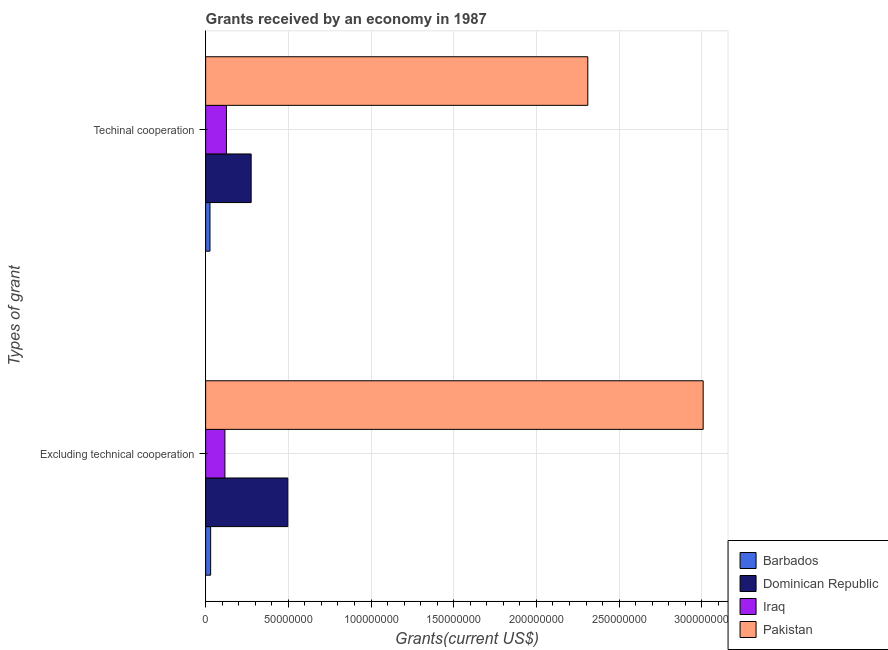How many groups of bars are there?
Your answer should be compact. 2. Are the number of bars on each tick of the Y-axis equal?
Provide a succinct answer. Yes. How many bars are there on the 1st tick from the bottom?
Give a very brief answer. 4. What is the label of the 2nd group of bars from the top?
Give a very brief answer. Excluding technical cooperation. What is the amount of grants received(including technical cooperation) in Dominican Republic?
Keep it short and to the point. 2.75e+07. Across all countries, what is the maximum amount of grants received(including technical cooperation)?
Provide a short and direct response. 2.31e+08. Across all countries, what is the minimum amount of grants received(including technical cooperation)?
Give a very brief answer. 2.63e+06. In which country was the amount of grants received(including technical cooperation) maximum?
Make the answer very short. Pakistan. In which country was the amount of grants received(excluding technical cooperation) minimum?
Your answer should be compact. Barbados. What is the total amount of grants received(including technical cooperation) in the graph?
Provide a succinct answer. 2.74e+08. What is the difference between the amount of grants received(including technical cooperation) in Dominican Republic and that in Barbados?
Provide a short and direct response. 2.49e+07. What is the difference between the amount of grants received(including technical cooperation) in Barbados and the amount of grants received(excluding technical cooperation) in Pakistan?
Your answer should be compact. -2.98e+08. What is the average amount of grants received(excluding technical cooperation) per country?
Provide a short and direct response. 9.13e+07. What is the difference between the amount of grants received(excluding technical cooperation) and amount of grants received(including technical cooperation) in Iraq?
Your response must be concise. -9.30e+05. In how many countries, is the amount of grants received(excluding technical cooperation) greater than 130000000 US$?
Your answer should be compact. 1. What is the ratio of the amount of grants received(excluding technical cooperation) in Dominican Republic to that in Pakistan?
Provide a succinct answer. 0.17. Is the amount of grants received(excluding technical cooperation) in Pakistan less than that in Dominican Republic?
Keep it short and to the point. No. In how many countries, is the amount of grants received(including technical cooperation) greater than the average amount of grants received(including technical cooperation) taken over all countries?
Keep it short and to the point. 1. What does the 4th bar from the top in Excluding technical cooperation represents?
Give a very brief answer. Barbados. What does the 2nd bar from the bottom in Excluding technical cooperation represents?
Provide a succinct answer. Dominican Republic. How many countries are there in the graph?
Provide a short and direct response. 4. What is the difference between two consecutive major ticks on the X-axis?
Your answer should be compact. 5.00e+07. Does the graph contain any zero values?
Offer a terse response. No. Does the graph contain grids?
Ensure brevity in your answer.  Yes. Where does the legend appear in the graph?
Keep it short and to the point. Bottom right. How many legend labels are there?
Your answer should be compact. 4. How are the legend labels stacked?
Your response must be concise. Vertical. What is the title of the graph?
Ensure brevity in your answer.  Grants received by an economy in 1987. What is the label or title of the X-axis?
Provide a short and direct response. Grants(current US$). What is the label or title of the Y-axis?
Your response must be concise. Types of grant. What is the Grants(current US$) of Barbados in Excluding technical cooperation?
Offer a terse response. 3.03e+06. What is the Grants(current US$) in Dominican Republic in Excluding technical cooperation?
Make the answer very short. 4.97e+07. What is the Grants(current US$) of Iraq in Excluding technical cooperation?
Offer a very short reply. 1.16e+07. What is the Grants(current US$) in Pakistan in Excluding technical cooperation?
Provide a succinct answer. 3.01e+08. What is the Grants(current US$) of Barbados in Techinal cooperation?
Provide a short and direct response. 2.63e+06. What is the Grants(current US$) of Dominican Republic in Techinal cooperation?
Your response must be concise. 2.75e+07. What is the Grants(current US$) in Iraq in Techinal cooperation?
Keep it short and to the point. 1.26e+07. What is the Grants(current US$) of Pakistan in Techinal cooperation?
Provide a short and direct response. 2.31e+08. Across all Types of grant, what is the maximum Grants(current US$) in Barbados?
Your response must be concise. 3.03e+06. Across all Types of grant, what is the maximum Grants(current US$) in Dominican Republic?
Your response must be concise. 4.97e+07. Across all Types of grant, what is the maximum Grants(current US$) in Iraq?
Your answer should be very brief. 1.26e+07. Across all Types of grant, what is the maximum Grants(current US$) of Pakistan?
Keep it short and to the point. 3.01e+08. Across all Types of grant, what is the minimum Grants(current US$) in Barbados?
Offer a terse response. 2.63e+06. Across all Types of grant, what is the minimum Grants(current US$) in Dominican Republic?
Provide a short and direct response. 2.75e+07. Across all Types of grant, what is the minimum Grants(current US$) in Iraq?
Your response must be concise. 1.16e+07. Across all Types of grant, what is the minimum Grants(current US$) in Pakistan?
Provide a short and direct response. 2.31e+08. What is the total Grants(current US$) of Barbados in the graph?
Your answer should be compact. 5.66e+06. What is the total Grants(current US$) in Dominican Republic in the graph?
Ensure brevity in your answer.  7.72e+07. What is the total Grants(current US$) in Iraq in the graph?
Your response must be concise. 2.42e+07. What is the total Grants(current US$) of Pakistan in the graph?
Provide a short and direct response. 5.32e+08. What is the difference between the Grants(current US$) in Dominican Republic in Excluding technical cooperation and that in Techinal cooperation?
Your response must be concise. 2.22e+07. What is the difference between the Grants(current US$) of Iraq in Excluding technical cooperation and that in Techinal cooperation?
Make the answer very short. -9.30e+05. What is the difference between the Grants(current US$) of Pakistan in Excluding technical cooperation and that in Techinal cooperation?
Your answer should be very brief. 6.98e+07. What is the difference between the Grants(current US$) in Barbados in Excluding technical cooperation and the Grants(current US$) in Dominican Republic in Techinal cooperation?
Offer a terse response. -2.45e+07. What is the difference between the Grants(current US$) in Barbados in Excluding technical cooperation and the Grants(current US$) in Iraq in Techinal cooperation?
Provide a short and direct response. -9.55e+06. What is the difference between the Grants(current US$) in Barbados in Excluding technical cooperation and the Grants(current US$) in Pakistan in Techinal cooperation?
Offer a terse response. -2.28e+08. What is the difference between the Grants(current US$) of Dominican Republic in Excluding technical cooperation and the Grants(current US$) of Iraq in Techinal cooperation?
Offer a very short reply. 3.71e+07. What is the difference between the Grants(current US$) of Dominican Republic in Excluding technical cooperation and the Grants(current US$) of Pakistan in Techinal cooperation?
Offer a very short reply. -1.81e+08. What is the difference between the Grants(current US$) in Iraq in Excluding technical cooperation and the Grants(current US$) in Pakistan in Techinal cooperation?
Your answer should be very brief. -2.19e+08. What is the average Grants(current US$) of Barbados per Types of grant?
Your answer should be compact. 2.83e+06. What is the average Grants(current US$) in Dominican Republic per Types of grant?
Your answer should be compact. 3.86e+07. What is the average Grants(current US$) of Iraq per Types of grant?
Your answer should be very brief. 1.21e+07. What is the average Grants(current US$) of Pakistan per Types of grant?
Provide a short and direct response. 2.66e+08. What is the difference between the Grants(current US$) in Barbados and Grants(current US$) in Dominican Republic in Excluding technical cooperation?
Provide a short and direct response. -4.66e+07. What is the difference between the Grants(current US$) of Barbados and Grants(current US$) of Iraq in Excluding technical cooperation?
Keep it short and to the point. -8.62e+06. What is the difference between the Grants(current US$) in Barbados and Grants(current US$) in Pakistan in Excluding technical cooperation?
Provide a short and direct response. -2.98e+08. What is the difference between the Grants(current US$) of Dominican Republic and Grants(current US$) of Iraq in Excluding technical cooperation?
Offer a very short reply. 3.80e+07. What is the difference between the Grants(current US$) of Dominican Republic and Grants(current US$) of Pakistan in Excluding technical cooperation?
Your answer should be very brief. -2.51e+08. What is the difference between the Grants(current US$) of Iraq and Grants(current US$) of Pakistan in Excluding technical cooperation?
Provide a short and direct response. -2.89e+08. What is the difference between the Grants(current US$) of Barbados and Grants(current US$) of Dominican Republic in Techinal cooperation?
Offer a terse response. -2.49e+07. What is the difference between the Grants(current US$) of Barbados and Grants(current US$) of Iraq in Techinal cooperation?
Make the answer very short. -9.95e+06. What is the difference between the Grants(current US$) in Barbados and Grants(current US$) in Pakistan in Techinal cooperation?
Your answer should be compact. -2.28e+08. What is the difference between the Grants(current US$) in Dominican Republic and Grants(current US$) in Iraq in Techinal cooperation?
Give a very brief answer. 1.49e+07. What is the difference between the Grants(current US$) of Dominican Republic and Grants(current US$) of Pakistan in Techinal cooperation?
Give a very brief answer. -2.04e+08. What is the difference between the Grants(current US$) of Iraq and Grants(current US$) of Pakistan in Techinal cooperation?
Provide a succinct answer. -2.18e+08. What is the ratio of the Grants(current US$) of Barbados in Excluding technical cooperation to that in Techinal cooperation?
Provide a succinct answer. 1.15. What is the ratio of the Grants(current US$) in Dominican Republic in Excluding technical cooperation to that in Techinal cooperation?
Provide a succinct answer. 1.81. What is the ratio of the Grants(current US$) of Iraq in Excluding technical cooperation to that in Techinal cooperation?
Provide a succinct answer. 0.93. What is the ratio of the Grants(current US$) of Pakistan in Excluding technical cooperation to that in Techinal cooperation?
Provide a succinct answer. 1.3. What is the difference between the highest and the second highest Grants(current US$) in Barbados?
Provide a short and direct response. 4.00e+05. What is the difference between the highest and the second highest Grants(current US$) in Dominican Republic?
Your answer should be very brief. 2.22e+07. What is the difference between the highest and the second highest Grants(current US$) of Iraq?
Your answer should be very brief. 9.30e+05. What is the difference between the highest and the second highest Grants(current US$) in Pakistan?
Offer a terse response. 6.98e+07. What is the difference between the highest and the lowest Grants(current US$) in Dominican Republic?
Provide a short and direct response. 2.22e+07. What is the difference between the highest and the lowest Grants(current US$) in Iraq?
Provide a short and direct response. 9.30e+05. What is the difference between the highest and the lowest Grants(current US$) of Pakistan?
Your answer should be compact. 6.98e+07. 